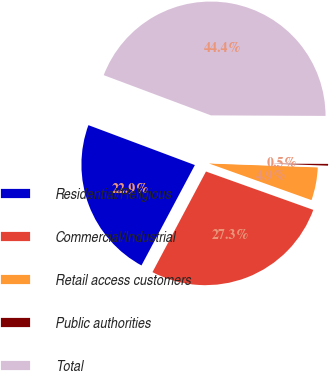<chart> <loc_0><loc_0><loc_500><loc_500><pie_chart><fcel>Residential/Religious<fcel>Commercial/Industrial<fcel>Retail access customers<fcel>Public authorities<fcel>Total<nl><fcel>22.93%<fcel>27.32%<fcel>4.89%<fcel>0.5%<fcel>44.37%<nl></chart> 